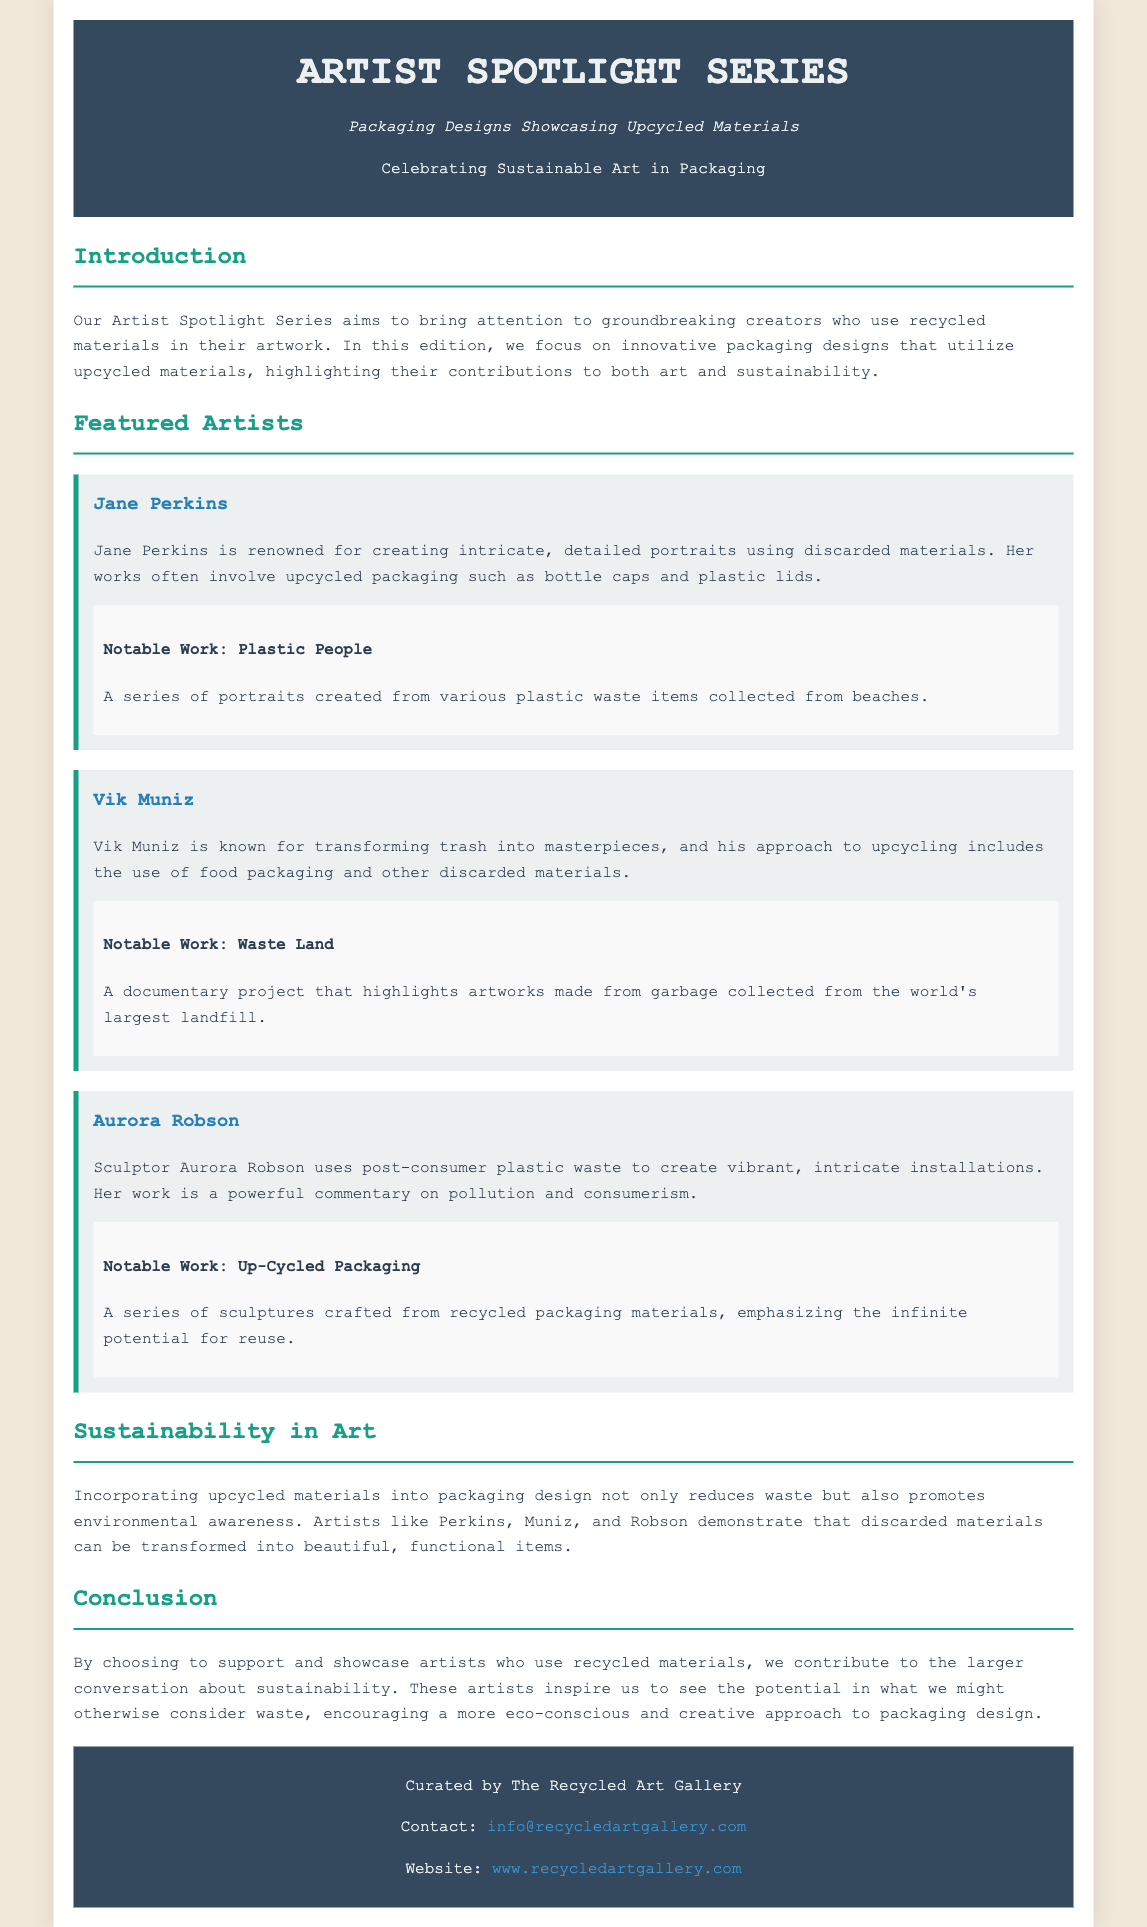What is the title of the series? The title of the series is mentioned prominently in the header section of the document.
Answer: Artist Spotlight Series Who is the first featured artist? The first featured artist is listed in the "Featured Artists" section.
Answer: Jane Perkins What materials does Jane Perkins primarily use in her work? The document describes the materials used by each artist, particularly in Jane Perkins' case.
Answer: Discarded materials What is the notable work of Vik Muniz? The notable work of each artist is provided in a specific section under their name.
Answer: Waste Land How does the document emphasize sustainability in art? The section on sustainability discusses the impact of upcycled materials on waste reduction and environmental awareness.
Answer: Reduces waste What commentary does Aurora Robson's work provide? The document states the themes of the artists' works, particularly for Aurora Robson.
Answer: Pollution and consumerism What is the subtitle of the document? The subtitle is provided just below the title in the header section.
Answer: Packaging Designs Showcasing Upcycled Materials Who curated this document? The curator's information is included in the footer of the document.
Answer: The Recycled Art Gallery What type of materials are highlighted in the packaging designs? The introduction mentions the focus on the specific type of materials used for packaging designs.
Answer: Upcycled materials 